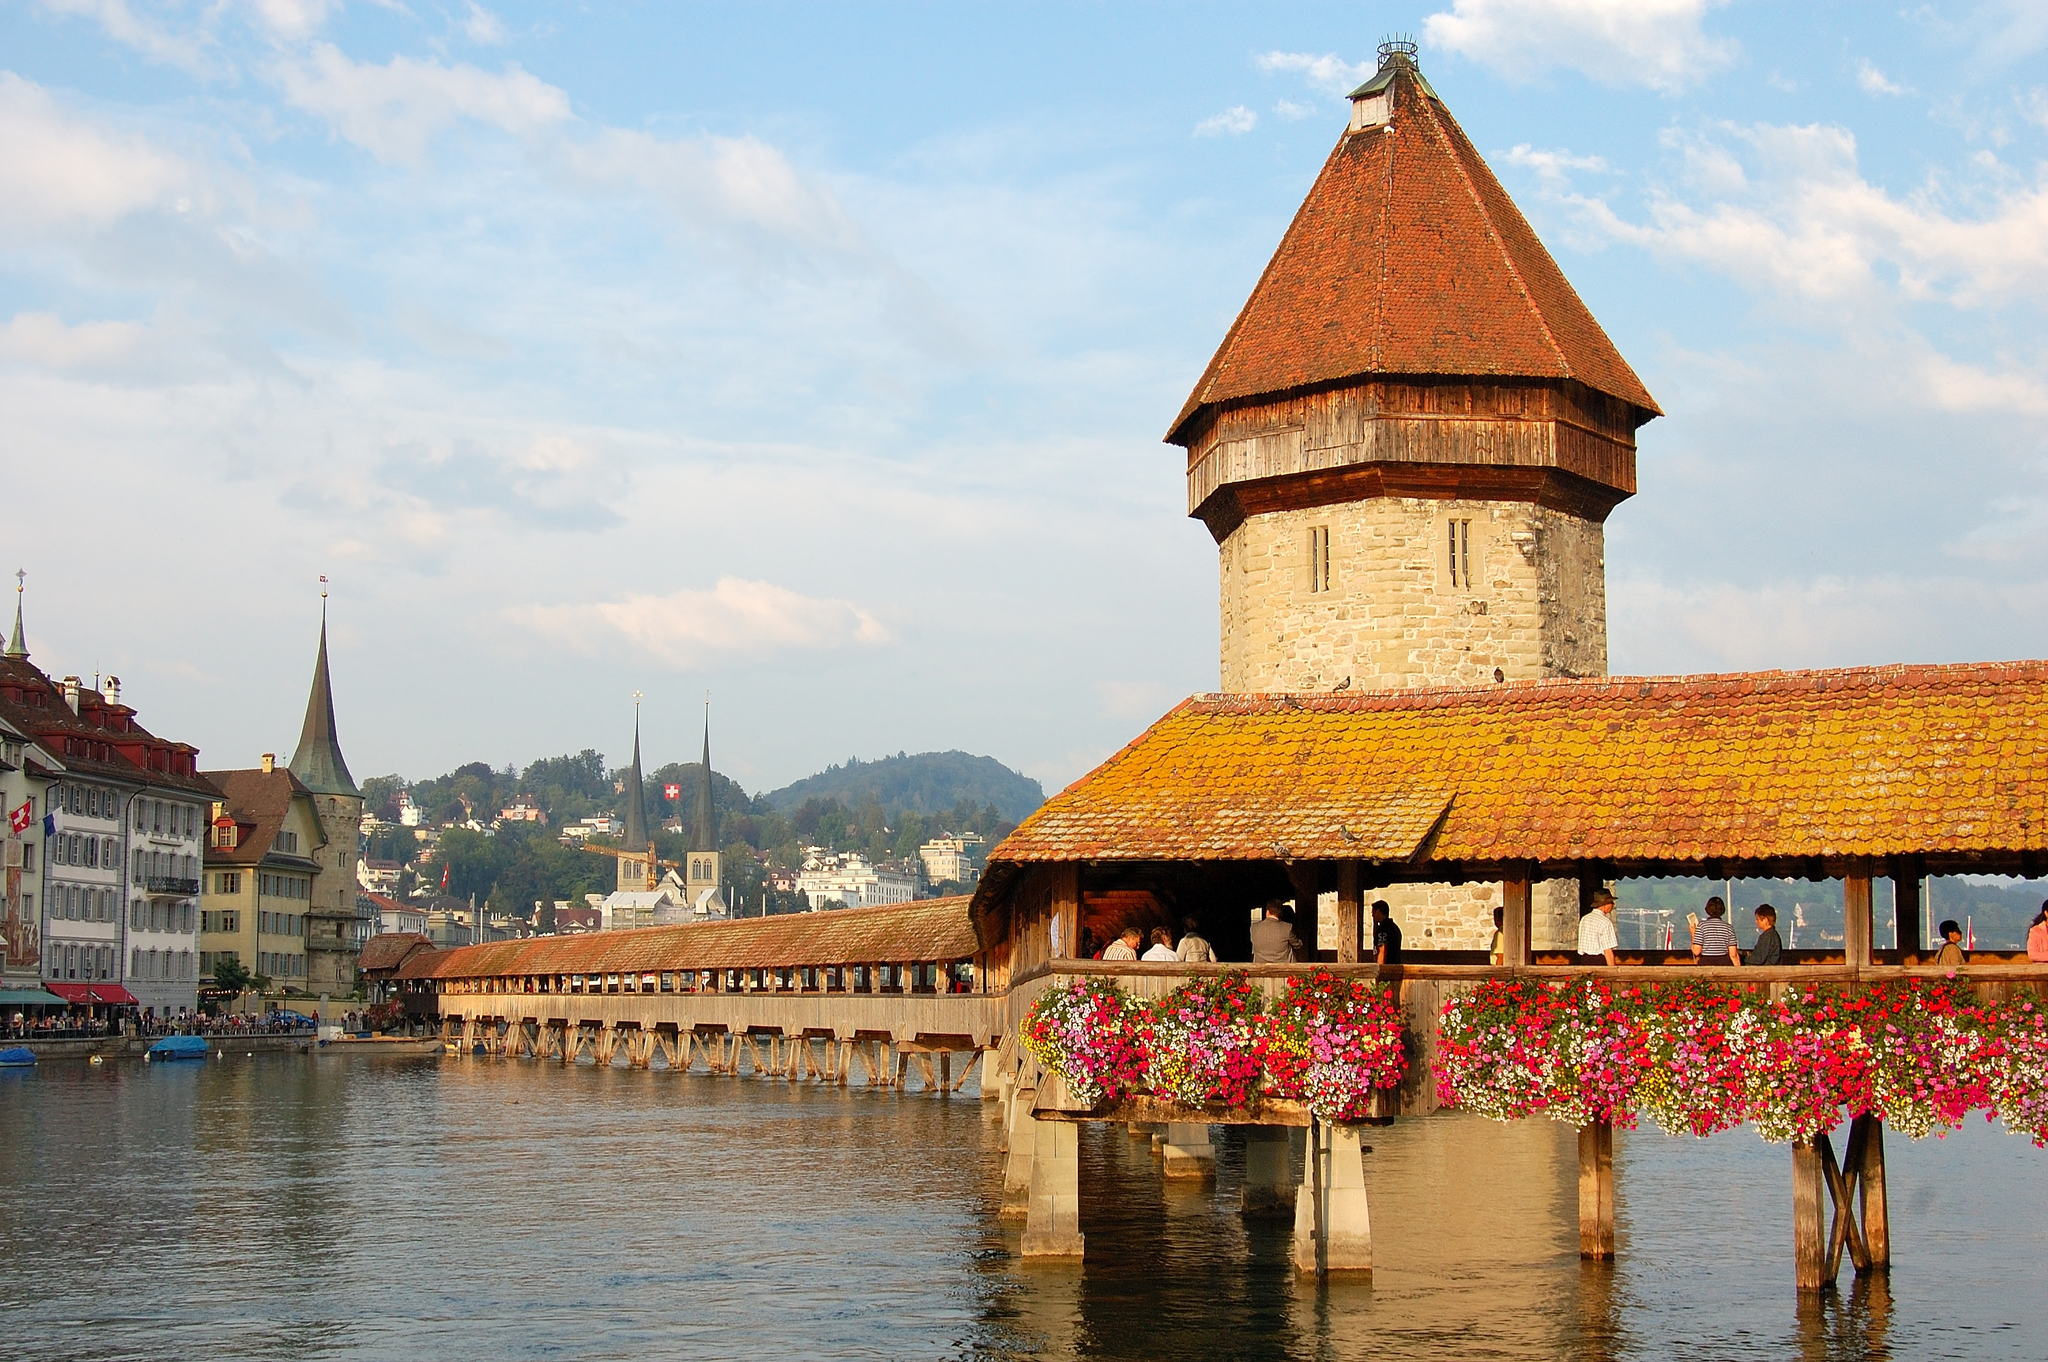What do you think the people on the bridge might be doing? The people walking along Chapel Bridge could be tourists or locals enjoying a leisurely stroll, appreciating the historical significance and scenic beauty of the bridge and its surroundings. They might be taking photographs, reading the narrative panels inside the bridge, or simply delighting in the vibrant display of flowers. Some could be heading to the various shops and cafes that line the riverbank, enjoying a day out in the picturesque city of Lucerne. 